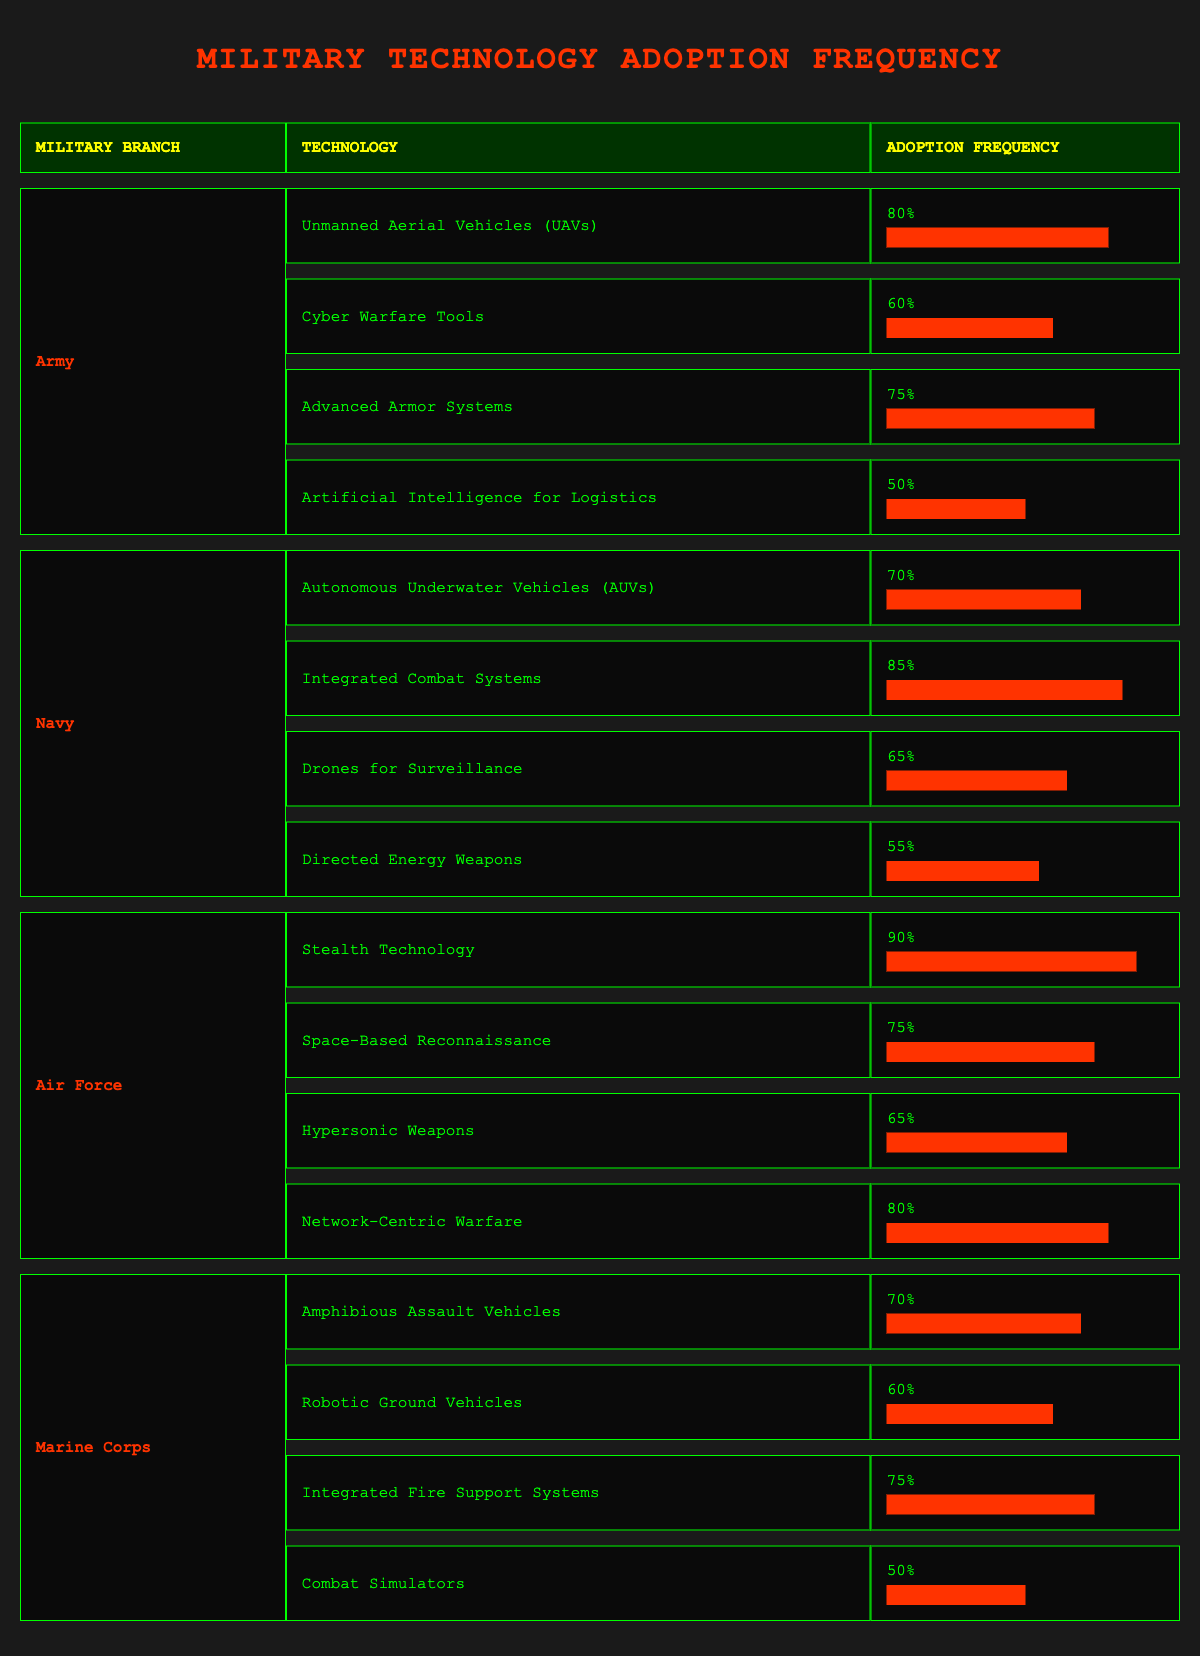What is the frequency of adoption for Stealth Technology in the Air Force? According to the table, the frequency for Stealth Technology is directly listed under the Air Force section. It shows a frequency of 90%.
Answer: 90% Which military branch has adopted the most technologies, and how many are there? By counting the technologies listed under each military branch, the Army, Navy, Air Force, and Marine Corps all have four technologies each. Therefore, they all have the same number of technologies adopted.
Answer: Army, Navy, Air Force, and Marine Corps each with 4 technologies What is the average frequency of technology adoption for the Navy? The adoption frequencies for the Navy are 70%, 85%, 65%, and 55%. First, sum them up: 70 + 85 + 65 + 55 = 275. Then divide by the number of technologies (4): 275/4 = 68.75%.
Answer: 68.75% True or False: The Marine Corps has a higher adoption frequency for Integrated Fire Support Systems than the Navy does for Autonomous Underwater Vehicles. The Marine Corps has a frequency of 75% for Integrated Fire Support Systems, while the Navy has 70% for Autonomous Underwater Vehicles. Therefore, the statement is true because 75% is greater than 70%.
Answer: True What is the difference in technology adoption frequency between the highest and lowest adopted technologies in the Army? The highest technology adoption frequency in the Army is for Unmanned Aerial Vehicles at 80%, and the lowest is for Artificial Intelligence for Logistics at 50%. The difference is calculated as 80% - 50% = 30%.
Answer: 30% 